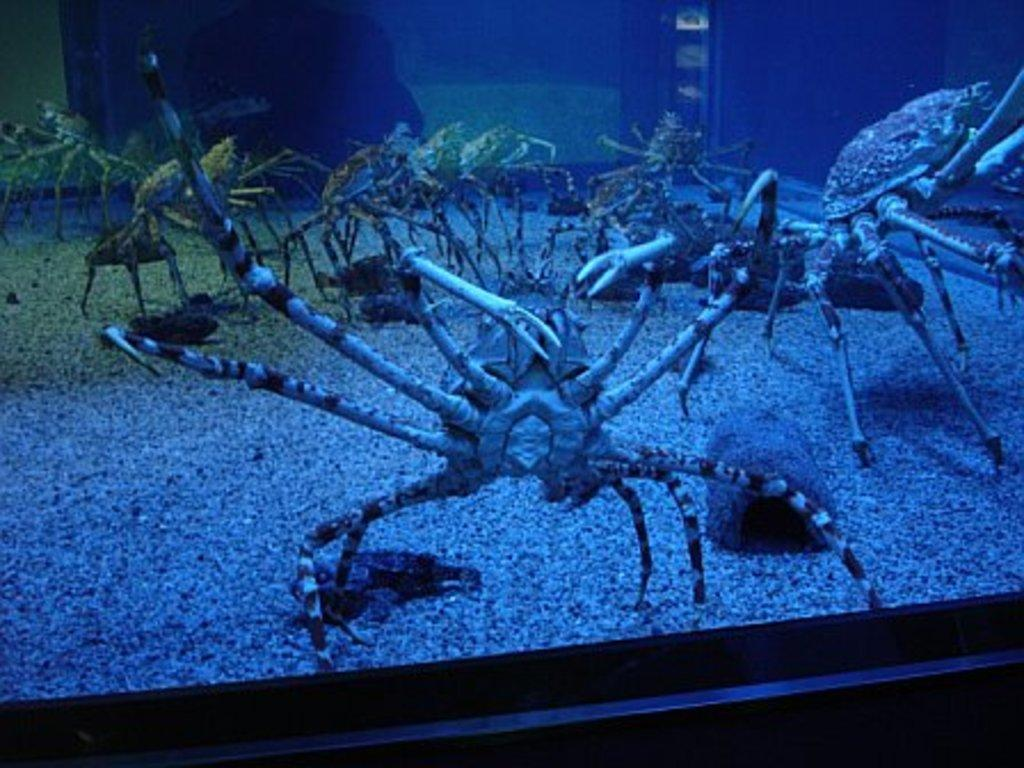What type of animals are present in the image? There are many spiders in the image. Can you describe the object in the image? Unfortunately, there is not enough information provided to describe the object in the image. What type of cave can be seen in the image? There is no cave present in the image. What type of juice is being consumed by the spiders in the image? There is no juice or any indication of consumption in the image. 